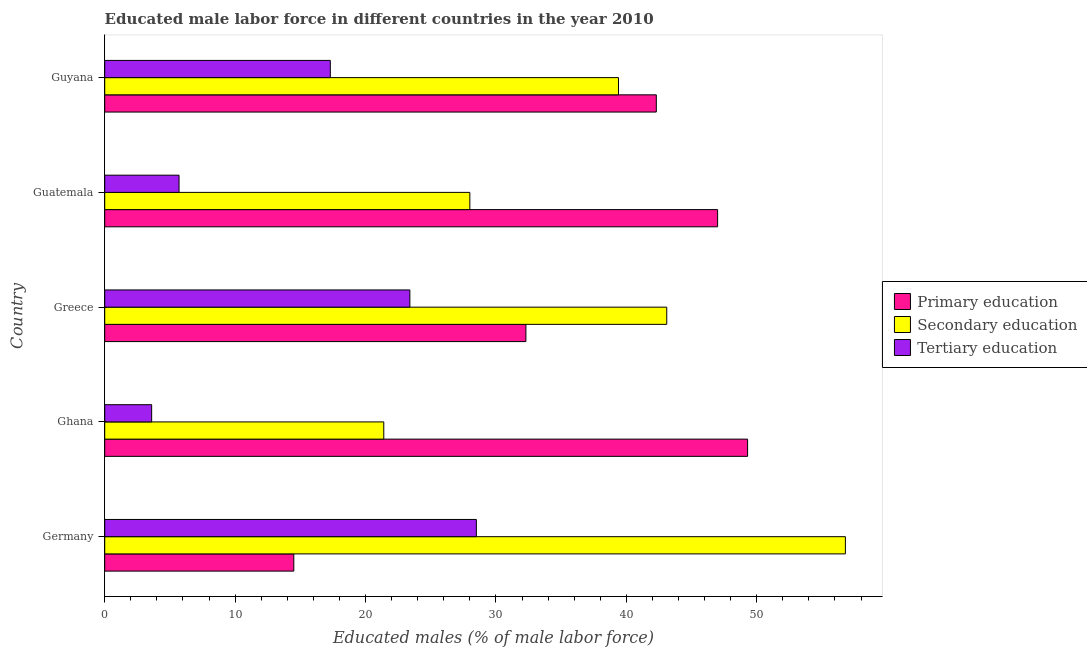How many bars are there on the 4th tick from the top?
Provide a short and direct response. 3. How many bars are there on the 3rd tick from the bottom?
Give a very brief answer. 3. What is the label of the 3rd group of bars from the top?
Your answer should be compact. Greece. In how many cases, is the number of bars for a given country not equal to the number of legend labels?
Your answer should be very brief. 0. What is the percentage of male labor force who received primary education in Ghana?
Your answer should be very brief. 49.3. Across all countries, what is the maximum percentage of male labor force who received secondary education?
Offer a very short reply. 56.8. Across all countries, what is the minimum percentage of male labor force who received secondary education?
Keep it short and to the point. 21.4. What is the total percentage of male labor force who received secondary education in the graph?
Offer a terse response. 188.7. What is the difference between the percentage of male labor force who received tertiary education in Ghana and that in Guyana?
Ensure brevity in your answer.  -13.7. What is the difference between the percentage of male labor force who received secondary education in Greece and the percentage of male labor force who received primary education in Germany?
Your response must be concise. 28.6. What is the average percentage of male labor force who received primary education per country?
Keep it short and to the point. 37.08. What is the ratio of the percentage of male labor force who received tertiary education in Germany to that in Guyana?
Offer a very short reply. 1.65. Is the percentage of male labor force who received secondary education in Greece less than that in Guyana?
Provide a short and direct response. No. What is the difference between the highest and the lowest percentage of male labor force who received primary education?
Your answer should be very brief. 34.8. Is the sum of the percentage of male labor force who received tertiary education in Germany and Greece greater than the maximum percentage of male labor force who received secondary education across all countries?
Offer a very short reply. No. What does the 1st bar from the top in Guyana represents?
Offer a very short reply. Tertiary education. What does the 3rd bar from the bottom in Guyana represents?
Ensure brevity in your answer.  Tertiary education. Is it the case that in every country, the sum of the percentage of male labor force who received primary education and percentage of male labor force who received secondary education is greater than the percentage of male labor force who received tertiary education?
Offer a terse response. Yes. How many bars are there?
Your answer should be very brief. 15. How many countries are there in the graph?
Provide a short and direct response. 5. Does the graph contain any zero values?
Keep it short and to the point. No. Does the graph contain grids?
Provide a succinct answer. No. How many legend labels are there?
Keep it short and to the point. 3. How are the legend labels stacked?
Provide a succinct answer. Vertical. What is the title of the graph?
Provide a short and direct response. Educated male labor force in different countries in the year 2010. Does "Profit Tax" appear as one of the legend labels in the graph?
Your response must be concise. No. What is the label or title of the X-axis?
Offer a very short reply. Educated males (% of male labor force). What is the label or title of the Y-axis?
Your response must be concise. Country. What is the Educated males (% of male labor force) in Secondary education in Germany?
Offer a very short reply. 56.8. What is the Educated males (% of male labor force) of Primary education in Ghana?
Keep it short and to the point. 49.3. What is the Educated males (% of male labor force) of Secondary education in Ghana?
Your answer should be compact. 21.4. What is the Educated males (% of male labor force) of Tertiary education in Ghana?
Provide a succinct answer. 3.6. What is the Educated males (% of male labor force) of Primary education in Greece?
Make the answer very short. 32.3. What is the Educated males (% of male labor force) in Secondary education in Greece?
Offer a very short reply. 43.1. What is the Educated males (% of male labor force) in Tertiary education in Greece?
Provide a short and direct response. 23.4. What is the Educated males (% of male labor force) in Secondary education in Guatemala?
Your answer should be very brief. 28. What is the Educated males (% of male labor force) in Tertiary education in Guatemala?
Your answer should be compact. 5.7. What is the Educated males (% of male labor force) in Primary education in Guyana?
Give a very brief answer. 42.3. What is the Educated males (% of male labor force) in Secondary education in Guyana?
Keep it short and to the point. 39.4. What is the Educated males (% of male labor force) in Tertiary education in Guyana?
Provide a succinct answer. 17.3. Across all countries, what is the maximum Educated males (% of male labor force) in Primary education?
Provide a succinct answer. 49.3. Across all countries, what is the maximum Educated males (% of male labor force) of Secondary education?
Provide a short and direct response. 56.8. Across all countries, what is the minimum Educated males (% of male labor force) in Secondary education?
Keep it short and to the point. 21.4. Across all countries, what is the minimum Educated males (% of male labor force) in Tertiary education?
Ensure brevity in your answer.  3.6. What is the total Educated males (% of male labor force) in Primary education in the graph?
Offer a terse response. 185.4. What is the total Educated males (% of male labor force) of Secondary education in the graph?
Your response must be concise. 188.7. What is the total Educated males (% of male labor force) of Tertiary education in the graph?
Ensure brevity in your answer.  78.5. What is the difference between the Educated males (% of male labor force) of Primary education in Germany and that in Ghana?
Provide a succinct answer. -34.8. What is the difference between the Educated males (% of male labor force) in Secondary education in Germany and that in Ghana?
Make the answer very short. 35.4. What is the difference between the Educated males (% of male labor force) in Tertiary education in Germany and that in Ghana?
Keep it short and to the point. 24.9. What is the difference between the Educated males (% of male labor force) in Primary education in Germany and that in Greece?
Provide a succinct answer. -17.8. What is the difference between the Educated males (% of male labor force) of Primary education in Germany and that in Guatemala?
Your response must be concise. -32.5. What is the difference between the Educated males (% of male labor force) in Secondary education in Germany and that in Guatemala?
Keep it short and to the point. 28.8. What is the difference between the Educated males (% of male labor force) of Tertiary education in Germany and that in Guatemala?
Keep it short and to the point. 22.8. What is the difference between the Educated males (% of male labor force) of Primary education in Germany and that in Guyana?
Your answer should be very brief. -27.8. What is the difference between the Educated males (% of male labor force) in Secondary education in Ghana and that in Greece?
Your response must be concise. -21.7. What is the difference between the Educated males (% of male labor force) of Tertiary education in Ghana and that in Greece?
Provide a succinct answer. -19.8. What is the difference between the Educated males (% of male labor force) in Secondary education in Ghana and that in Guatemala?
Offer a terse response. -6.6. What is the difference between the Educated males (% of male labor force) of Tertiary education in Ghana and that in Guatemala?
Your answer should be very brief. -2.1. What is the difference between the Educated males (% of male labor force) of Primary education in Ghana and that in Guyana?
Provide a succinct answer. 7. What is the difference between the Educated males (% of male labor force) of Secondary education in Ghana and that in Guyana?
Provide a succinct answer. -18. What is the difference between the Educated males (% of male labor force) in Tertiary education in Ghana and that in Guyana?
Offer a terse response. -13.7. What is the difference between the Educated males (% of male labor force) of Primary education in Greece and that in Guatemala?
Your response must be concise. -14.7. What is the difference between the Educated males (% of male labor force) in Tertiary education in Greece and that in Guatemala?
Your answer should be compact. 17.7. What is the difference between the Educated males (% of male labor force) of Primary education in Germany and the Educated males (% of male labor force) of Secondary education in Ghana?
Your response must be concise. -6.9. What is the difference between the Educated males (% of male labor force) in Secondary education in Germany and the Educated males (% of male labor force) in Tertiary education in Ghana?
Give a very brief answer. 53.2. What is the difference between the Educated males (% of male labor force) in Primary education in Germany and the Educated males (% of male labor force) in Secondary education in Greece?
Make the answer very short. -28.6. What is the difference between the Educated males (% of male labor force) of Primary education in Germany and the Educated males (% of male labor force) of Tertiary education in Greece?
Provide a short and direct response. -8.9. What is the difference between the Educated males (% of male labor force) of Secondary education in Germany and the Educated males (% of male labor force) of Tertiary education in Greece?
Provide a succinct answer. 33.4. What is the difference between the Educated males (% of male labor force) of Secondary education in Germany and the Educated males (% of male labor force) of Tertiary education in Guatemala?
Keep it short and to the point. 51.1. What is the difference between the Educated males (% of male labor force) of Primary education in Germany and the Educated males (% of male labor force) of Secondary education in Guyana?
Provide a succinct answer. -24.9. What is the difference between the Educated males (% of male labor force) in Primary education in Germany and the Educated males (% of male labor force) in Tertiary education in Guyana?
Offer a terse response. -2.8. What is the difference between the Educated males (% of male labor force) in Secondary education in Germany and the Educated males (% of male labor force) in Tertiary education in Guyana?
Offer a very short reply. 39.5. What is the difference between the Educated males (% of male labor force) of Primary education in Ghana and the Educated males (% of male labor force) of Tertiary education in Greece?
Provide a succinct answer. 25.9. What is the difference between the Educated males (% of male labor force) of Secondary education in Ghana and the Educated males (% of male labor force) of Tertiary education in Greece?
Offer a very short reply. -2. What is the difference between the Educated males (% of male labor force) of Primary education in Ghana and the Educated males (% of male labor force) of Secondary education in Guatemala?
Give a very brief answer. 21.3. What is the difference between the Educated males (% of male labor force) of Primary education in Ghana and the Educated males (% of male labor force) of Tertiary education in Guatemala?
Your answer should be very brief. 43.6. What is the difference between the Educated males (% of male labor force) of Primary education in Ghana and the Educated males (% of male labor force) of Secondary education in Guyana?
Provide a succinct answer. 9.9. What is the difference between the Educated males (% of male labor force) in Primary education in Ghana and the Educated males (% of male labor force) in Tertiary education in Guyana?
Provide a succinct answer. 32. What is the difference between the Educated males (% of male labor force) of Primary education in Greece and the Educated males (% of male labor force) of Tertiary education in Guatemala?
Your answer should be compact. 26.6. What is the difference between the Educated males (% of male labor force) of Secondary education in Greece and the Educated males (% of male labor force) of Tertiary education in Guatemala?
Make the answer very short. 37.4. What is the difference between the Educated males (% of male labor force) in Primary education in Greece and the Educated males (% of male labor force) in Secondary education in Guyana?
Your answer should be very brief. -7.1. What is the difference between the Educated males (% of male labor force) of Secondary education in Greece and the Educated males (% of male labor force) of Tertiary education in Guyana?
Your answer should be compact. 25.8. What is the difference between the Educated males (% of male labor force) of Primary education in Guatemala and the Educated males (% of male labor force) of Tertiary education in Guyana?
Provide a short and direct response. 29.7. What is the average Educated males (% of male labor force) in Primary education per country?
Give a very brief answer. 37.08. What is the average Educated males (% of male labor force) of Secondary education per country?
Offer a terse response. 37.74. What is the difference between the Educated males (% of male labor force) of Primary education and Educated males (% of male labor force) of Secondary education in Germany?
Provide a short and direct response. -42.3. What is the difference between the Educated males (% of male labor force) of Secondary education and Educated males (% of male labor force) of Tertiary education in Germany?
Keep it short and to the point. 28.3. What is the difference between the Educated males (% of male labor force) of Primary education and Educated males (% of male labor force) of Secondary education in Ghana?
Your response must be concise. 27.9. What is the difference between the Educated males (% of male labor force) of Primary education and Educated males (% of male labor force) of Tertiary education in Ghana?
Your answer should be compact. 45.7. What is the difference between the Educated males (% of male labor force) of Secondary education and Educated males (% of male labor force) of Tertiary education in Ghana?
Offer a very short reply. 17.8. What is the difference between the Educated males (% of male labor force) in Primary education and Educated males (% of male labor force) in Secondary education in Greece?
Your answer should be very brief. -10.8. What is the difference between the Educated males (% of male labor force) of Primary education and Educated males (% of male labor force) of Tertiary education in Guatemala?
Your answer should be compact. 41.3. What is the difference between the Educated males (% of male labor force) of Secondary education and Educated males (% of male labor force) of Tertiary education in Guatemala?
Your answer should be very brief. 22.3. What is the difference between the Educated males (% of male labor force) in Secondary education and Educated males (% of male labor force) in Tertiary education in Guyana?
Ensure brevity in your answer.  22.1. What is the ratio of the Educated males (% of male labor force) in Primary education in Germany to that in Ghana?
Make the answer very short. 0.29. What is the ratio of the Educated males (% of male labor force) of Secondary education in Germany to that in Ghana?
Offer a terse response. 2.65. What is the ratio of the Educated males (% of male labor force) of Tertiary education in Germany to that in Ghana?
Ensure brevity in your answer.  7.92. What is the ratio of the Educated males (% of male labor force) in Primary education in Germany to that in Greece?
Offer a very short reply. 0.45. What is the ratio of the Educated males (% of male labor force) of Secondary education in Germany to that in Greece?
Offer a very short reply. 1.32. What is the ratio of the Educated males (% of male labor force) in Tertiary education in Germany to that in Greece?
Provide a short and direct response. 1.22. What is the ratio of the Educated males (% of male labor force) in Primary education in Germany to that in Guatemala?
Your response must be concise. 0.31. What is the ratio of the Educated males (% of male labor force) of Secondary education in Germany to that in Guatemala?
Offer a terse response. 2.03. What is the ratio of the Educated males (% of male labor force) in Tertiary education in Germany to that in Guatemala?
Provide a short and direct response. 5. What is the ratio of the Educated males (% of male labor force) in Primary education in Germany to that in Guyana?
Ensure brevity in your answer.  0.34. What is the ratio of the Educated males (% of male labor force) in Secondary education in Germany to that in Guyana?
Your answer should be very brief. 1.44. What is the ratio of the Educated males (% of male labor force) of Tertiary education in Germany to that in Guyana?
Your answer should be very brief. 1.65. What is the ratio of the Educated males (% of male labor force) in Primary education in Ghana to that in Greece?
Your response must be concise. 1.53. What is the ratio of the Educated males (% of male labor force) of Secondary education in Ghana to that in Greece?
Your answer should be very brief. 0.5. What is the ratio of the Educated males (% of male labor force) in Tertiary education in Ghana to that in Greece?
Ensure brevity in your answer.  0.15. What is the ratio of the Educated males (% of male labor force) of Primary education in Ghana to that in Guatemala?
Your response must be concise. 1.05. What is the ratio of the Educated males (% of male labor force) in Secondary education in Ghana to that in Guatemala?
Your response must be concise. 0.76. What is the ratio of the Educated males (% of male labor force) in Tertiary education in Ghana to that in Guatemala?
Offer a very short reply. 0.63. What is the ratio of the Educated males (% of male labor force) in Primary education in Ghana to that in Guyana?
Make the answer very short. 1.17. What is the ratio of the Educated males (% of male labor force) in Secondary education in Ghana to that in Guyana?
Your response must be concise. 0.54. What is the ratio of the Educated males (% of male labor force) of Tertiary education in Ghana to that in Guyana?
Your response must be concise. 0.21. What is the ratio of the Educated males (% of male labor force) in Primary education in Greece to that in Guatemala?
Provide a short and direct response. 0.69. What is the ratio of the Educated males (% of male labor force) of Secondary education in Greece to that in Guatemala?
Your answer should be compact. 1.54. What is the ratio of the Educated males (% of male labor force) in Tertiary education in Greece to that in Guatemala?
Ensure brevity in your answer.  4.11. What is the ratio of the Educated males (% of male labor force) of Primary education in Greece to that in Guyana?
Your response must be concise. 0.76. What is the ratio of the Educated males (% of male labor force) of Secondary education in Greece to that in Guyana?
Ensure brevity in your answer.  1.09. What is the ratio of the Educated males (% of male labor force) of Tertiary education in Greece to that in Guyana?
Your answer should be compact. 1.35. What is the ratio of the Educated males (% of male labor force) in Primary education in Guatemala to that in Guyana?
Keep it short and to the point. 1.11. What is the ratio of the Educated males (% of male labor force) in Secondary education in Guatemala to that in Guyana?
Keep it short and to the point. 0.71. What is the ratio of the Educated males (% of male labor force) of Tertiary education in Guatemala to that in Guyana?
Your answer should be very brief. 0.33. What is the difference between the highest and the second highest Educated males (% of male labor force) in Secondary education?
Offer a terse response. 13.7. What is the difference between the highest and the lowest Educated males (% of male labor force) of Primary education?
Keep it short and to the point. 34.8. What is the difference between the highest and the lowest Educated males (% of male labor force) of Secondary education?
Give a very brief answer. 35.4. What is the difference between the highest and the lowest Educated males (% of male labor force) of Tertiary education?
Offer a terse response. 24.9. 